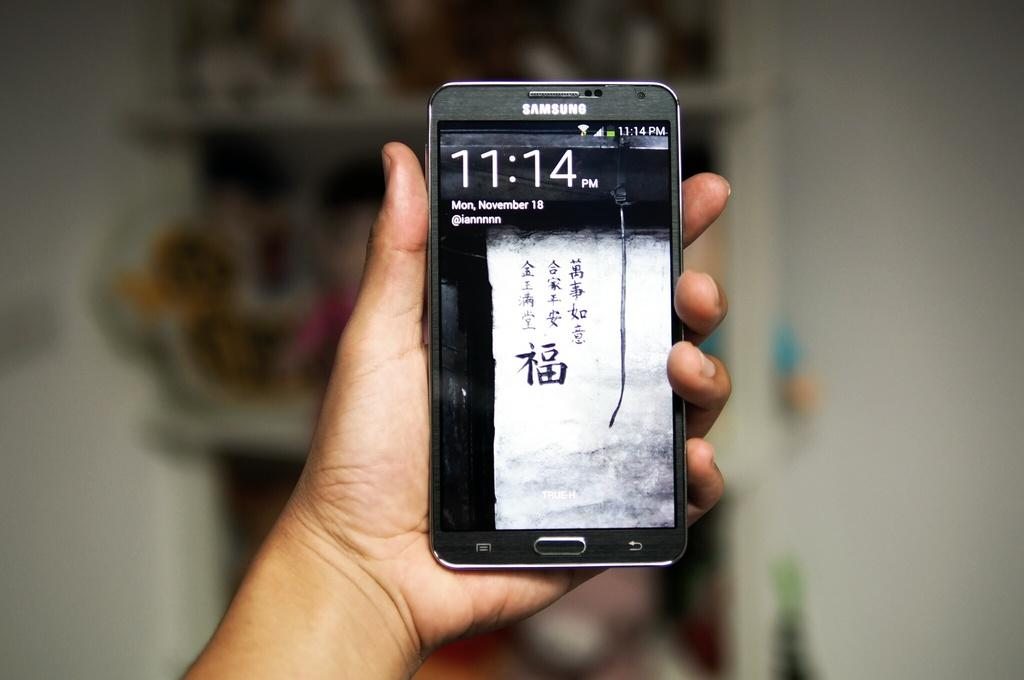<image>
Relay a brief, clear account of the picture shown. Hand holding black Samsung phone reading 11:14 and showing Chinese characters 